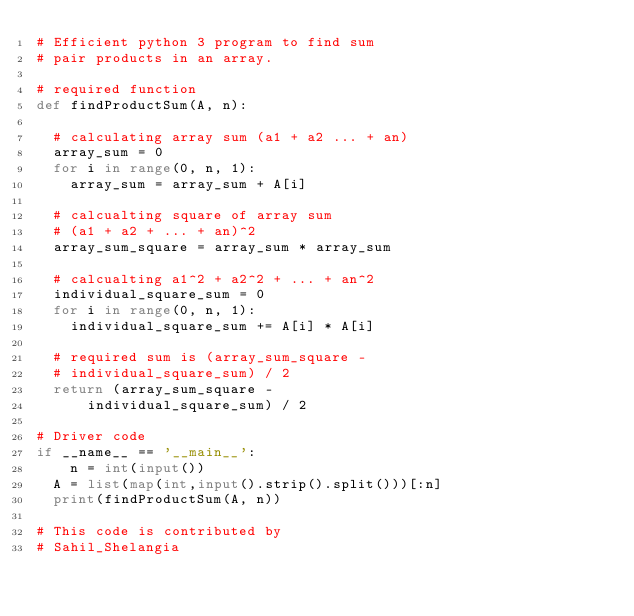Convert code to text. <code><loc_0><loc_0><loc_500><loc_500><_Python_># Efficient python 3 program to find sum 
# pair products in an array. 

# required function 
def findProductSum(A, n): 
	
	# calculating array sum (a1 + a2 ... + an) 
	array_sum = 0
	for i in range(0, n, 1): 
		array_sum = array_sum + A[i] 

	# calcualting square of array sum 
	# (a1 + a2 + ... + an)^2 
	array_sum_square = array_sum * array_sum 

	# calcualting a1^2 + a2^2 + ... + an^2 
	individual_square_sum = 0
	for i in range(0, n, 1): 
		individual_square_sum += A[i] * A[i] 

	# required sum is (array_sum_square - 
	# individual_square_sum) / 2 
	return (array_sum_square -
			individual_square_sum) / 2

# Driver code 
if __name__ == '__main__': 
  	n = int(input())
	A = list(map(int,input().strip().split()))[:n] 
	print(findProductSum(A, n))
	
# This code is contributed by 
# Sahil_Shelangia 
</code> 